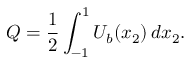<formula> <loc_0><loc_0><loc_500><loc_500>Q = \frac { 1 } { 2 } \int _ { - 1 } ^ { 1 } U _ { b } ( x _ { 2 } ) \, d x _ { 2 } .</formula> 